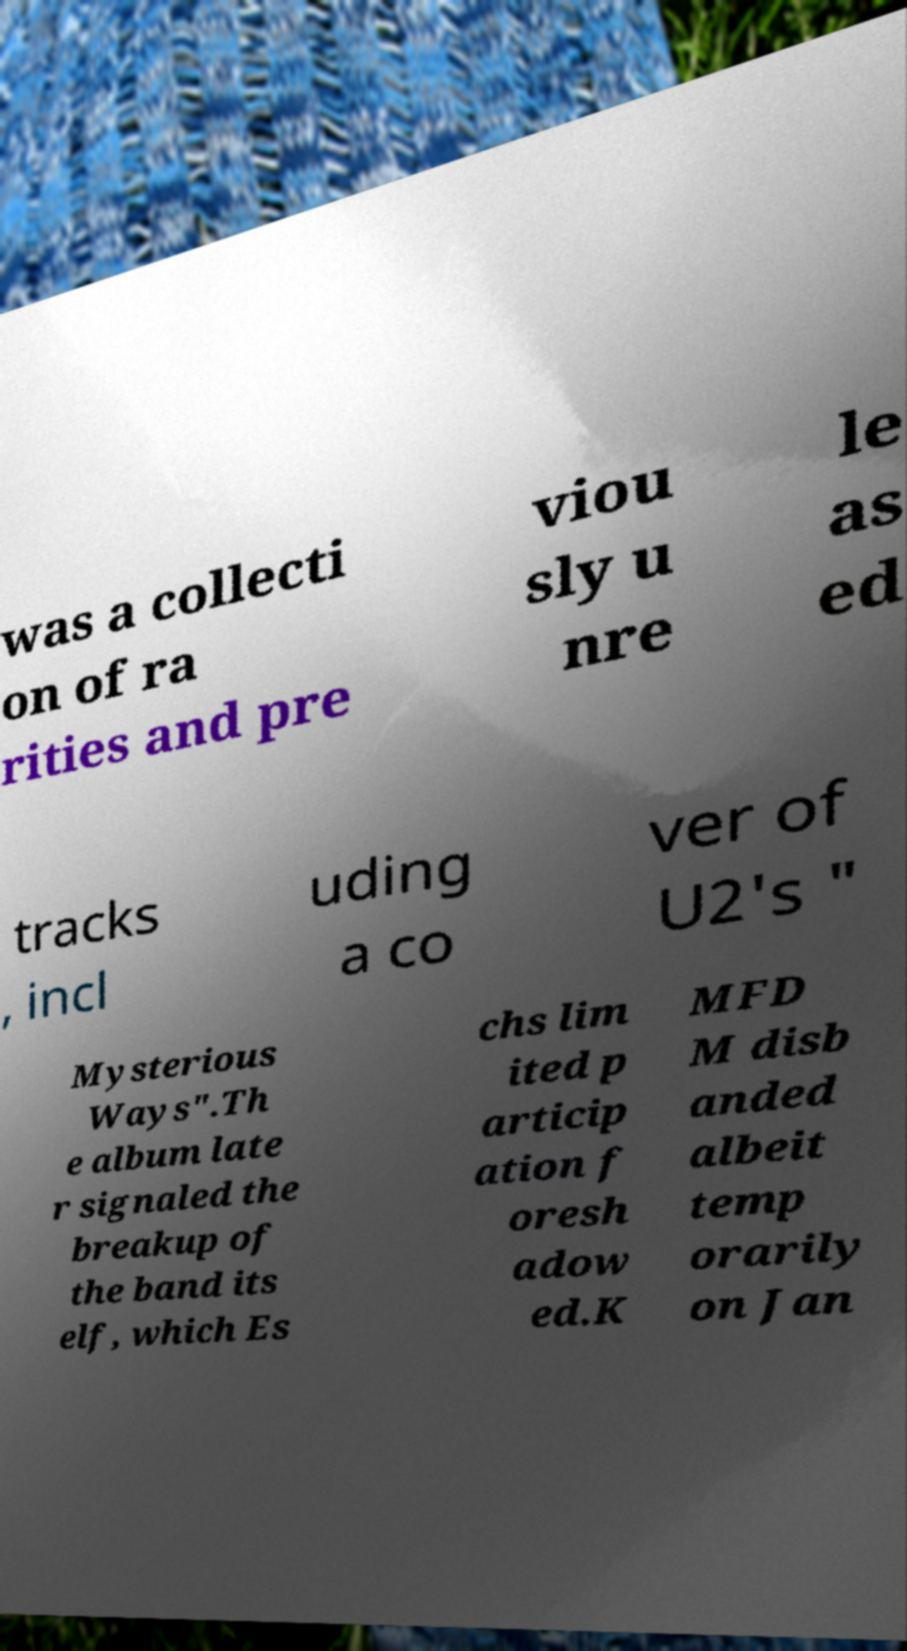What messages or text are displayed in this image? I need them in a readable, typed format. was a collecti on of ra rities and pre viou sly u nre le as ed tracks , incl uding a co ver of U2's " Mysterious Ways".Th e album late r signaled the breakup of the band its elf, which Es chs lim ited p articip ation f oresh adow ed.K MFD M disb anded albeit temp orarily on Jan 